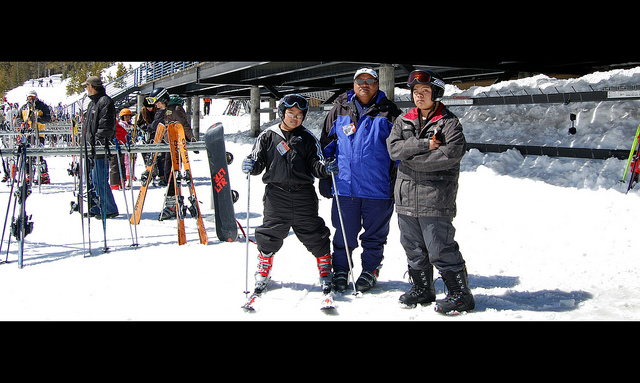Can you tell which person seems most prepared for skiing and why? The person on the left appears most prepared for skiing. He is the only one wearing skis, and his posture suggests readiness and enthusiasm for skiing, with skis attached and poles in hand, indicating he's all set for the activity. 